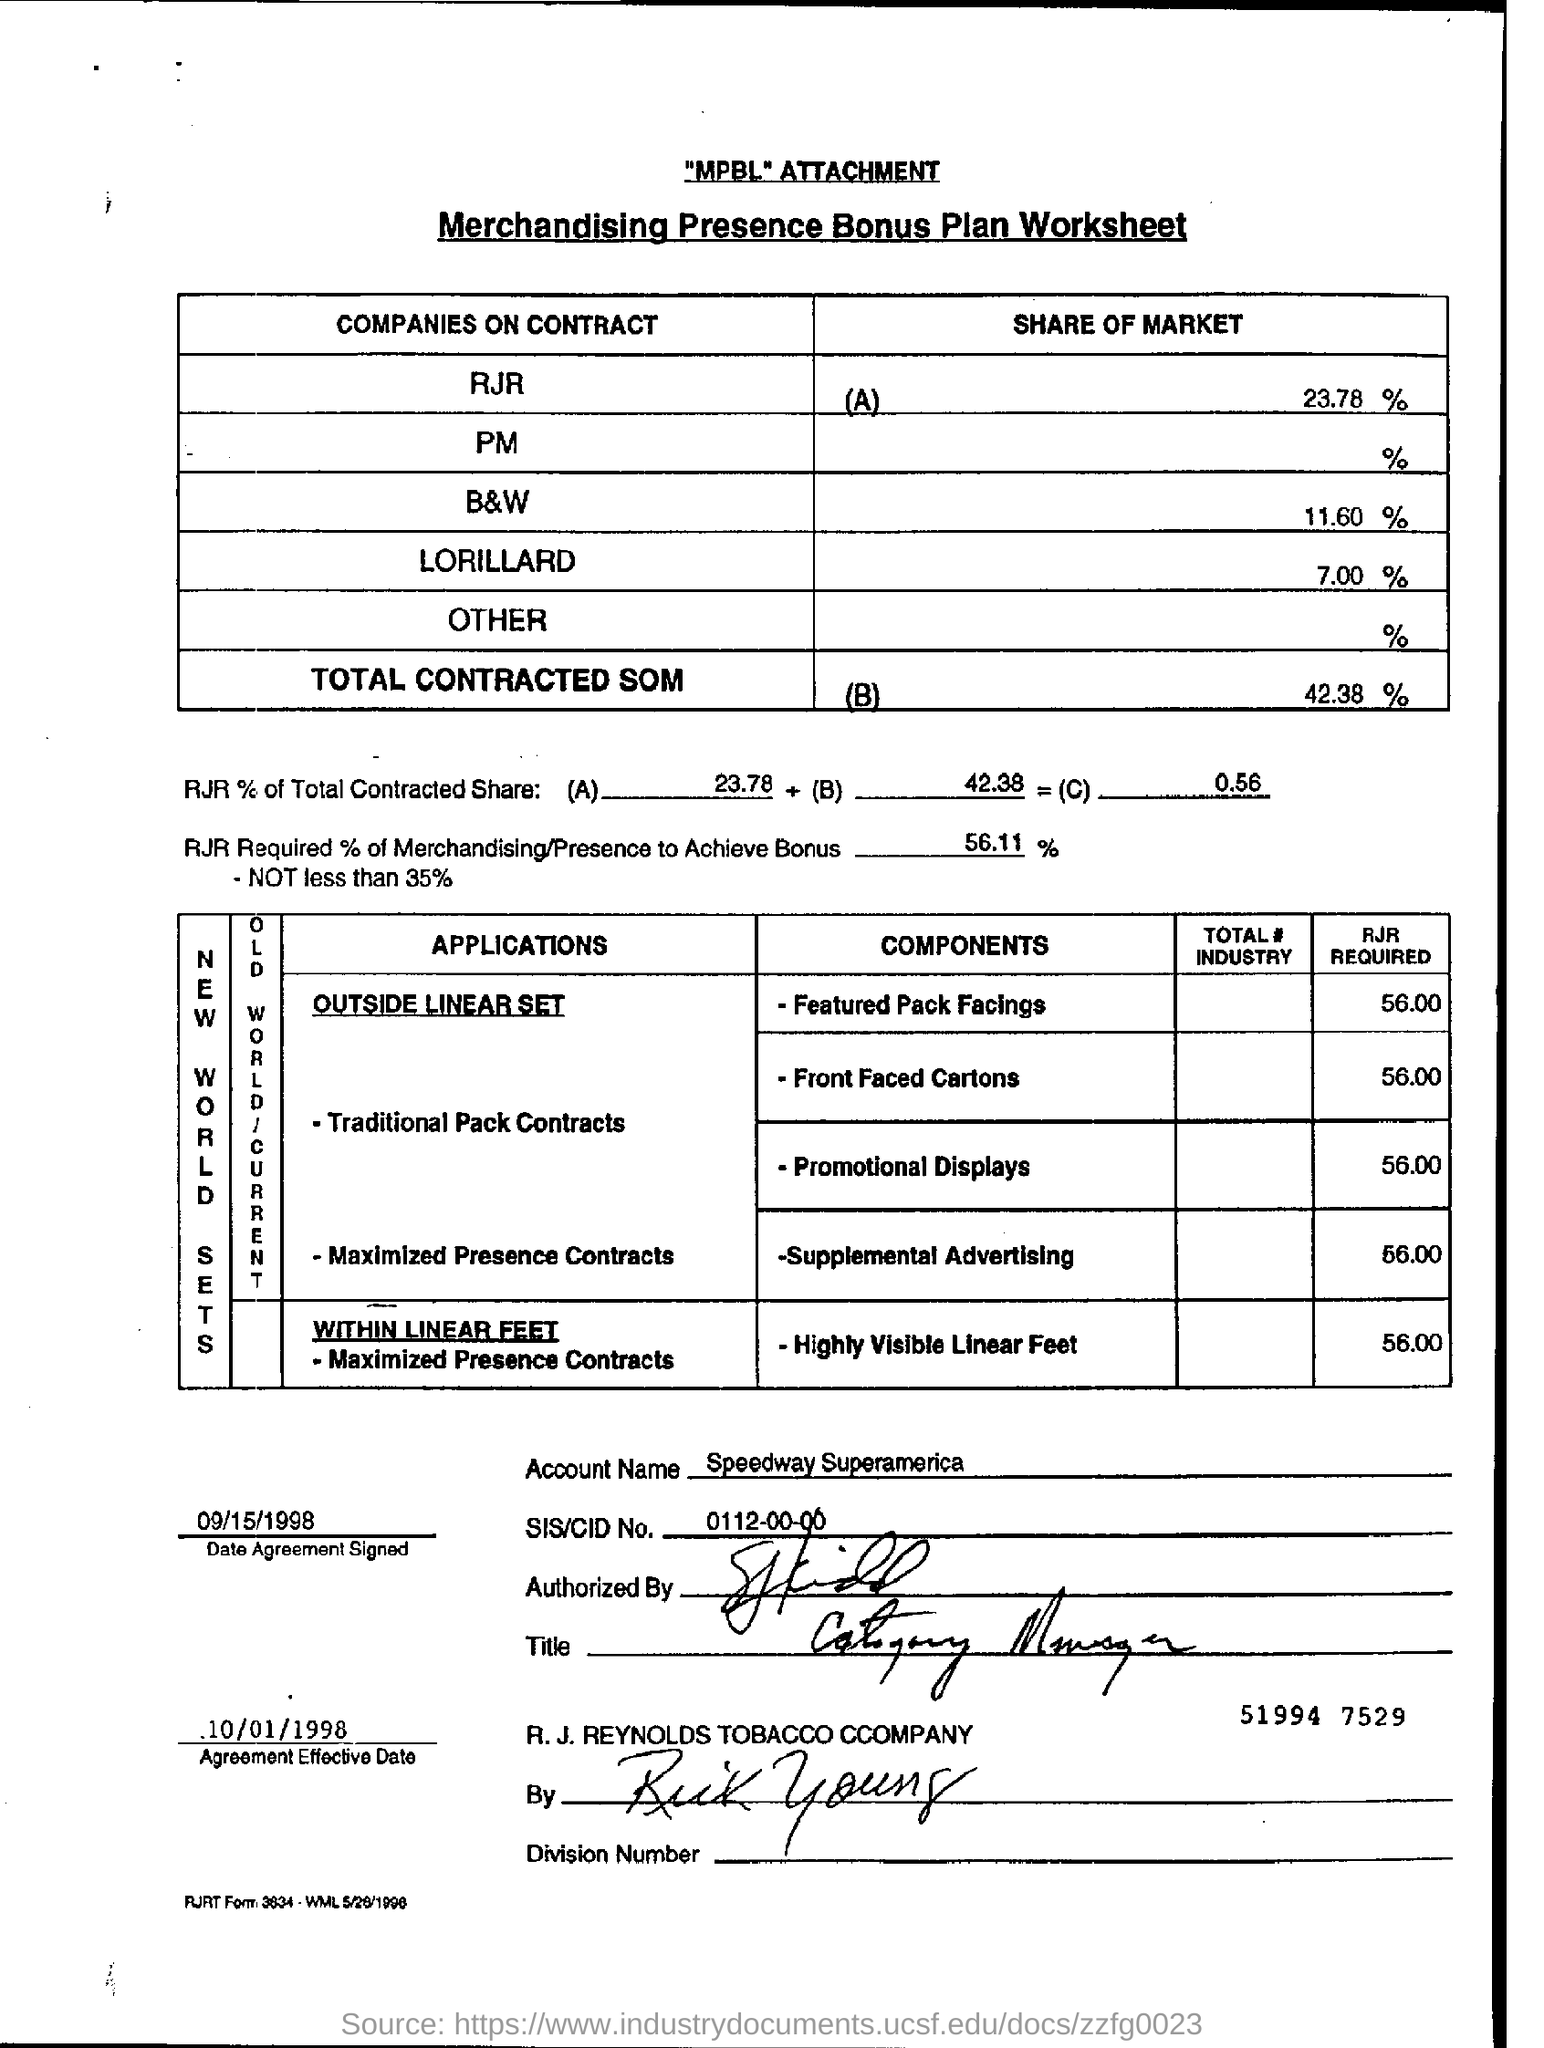Identify some key points in this picture. The account name mentioned is "Speedway Superamerica. The amount required for supplemental advertising is RJR 56.00. What is the SIS/CID number mentioned? It is 0112-00-00... The share of market of companies on contract - black and white is 11.60%. 